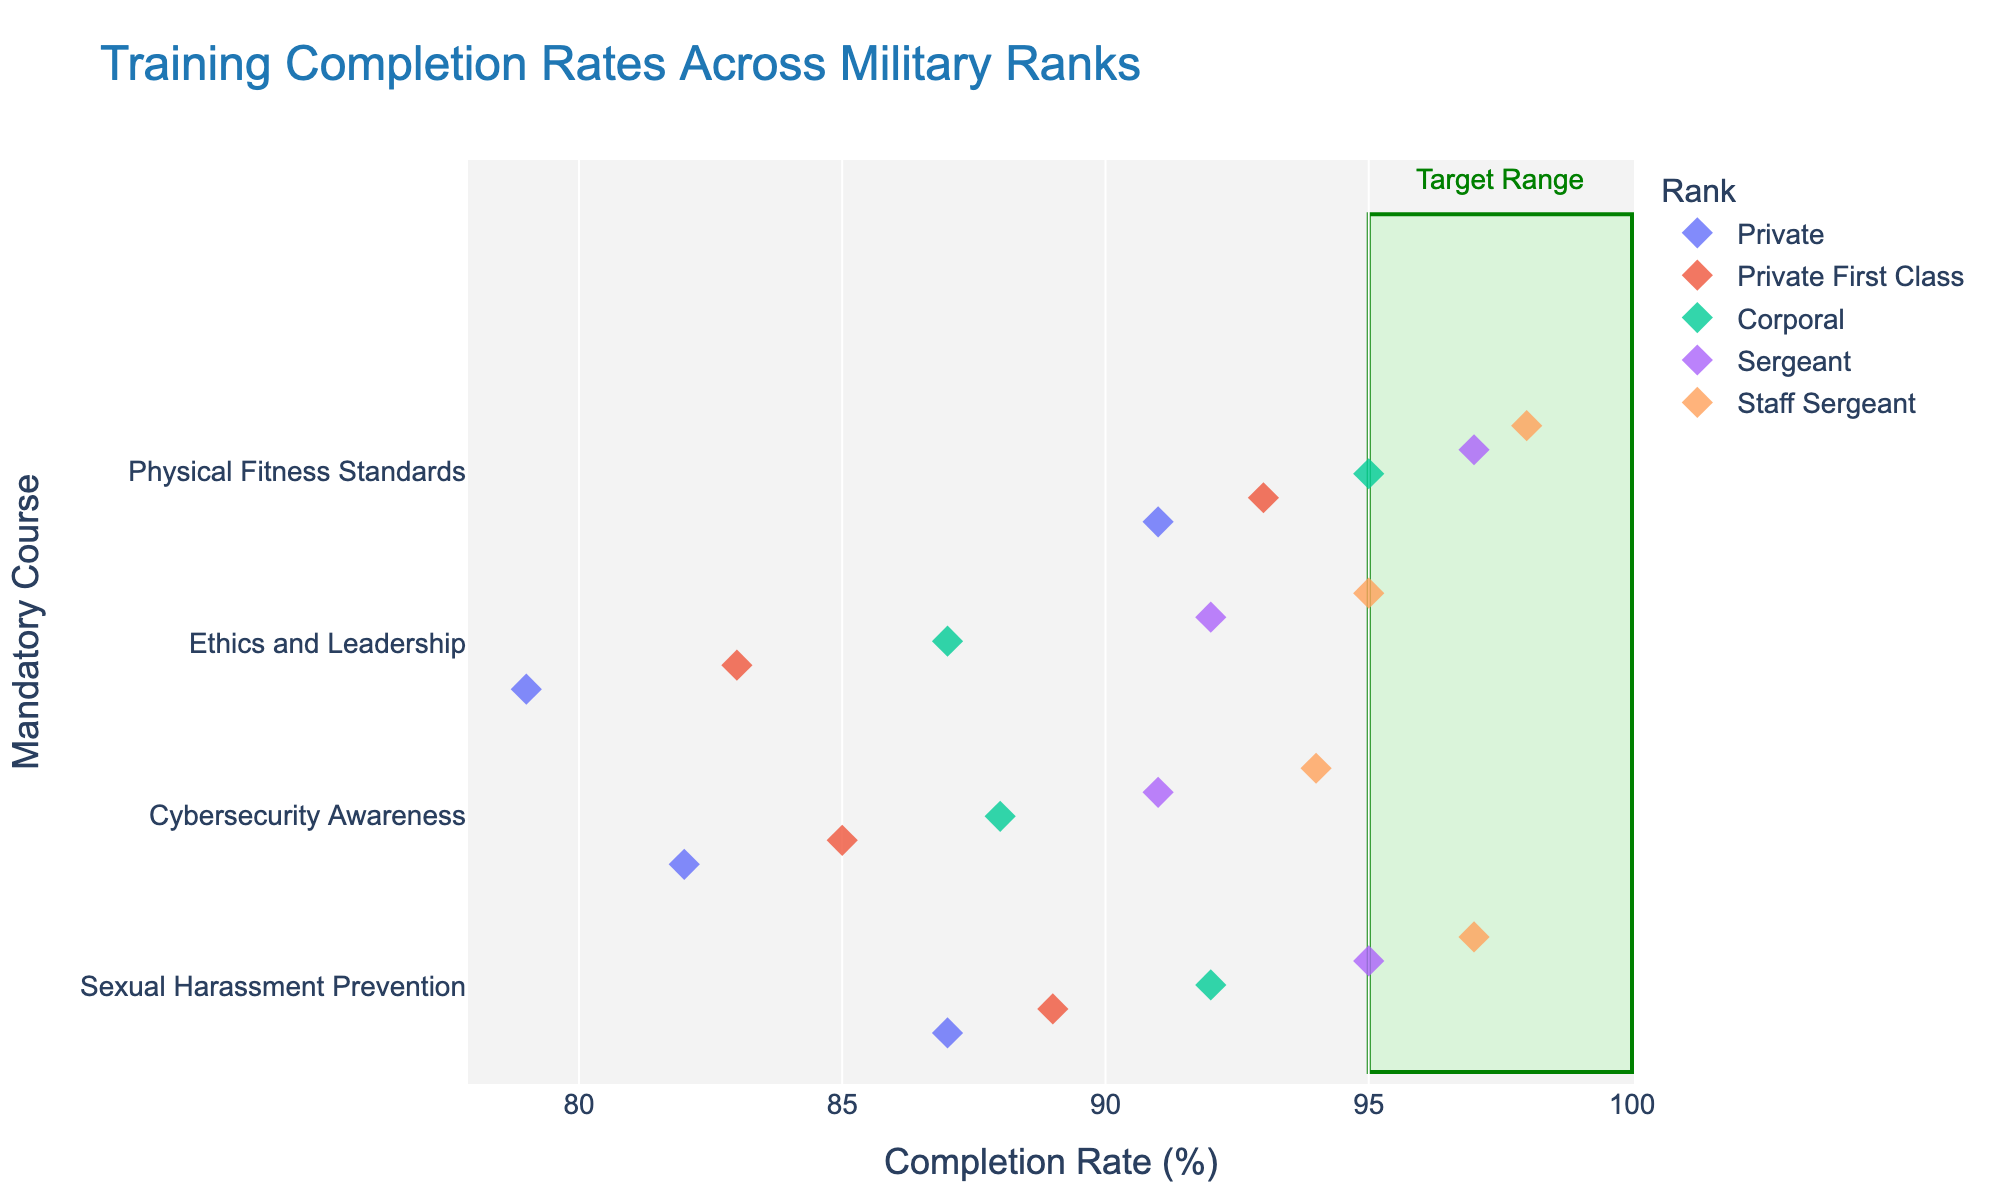what is the title of the figure? The title of the figure is displayed at the top and is often larger and bolder than other text elements.
Answer: Training Completion Rates Across Military Ranks What does the x-axis represent? The x-axis represents the "Completion Rate (%)" for the mandatory courses.
Answer: Completion Rate (%) How many distinct ranks are shown in the figure? The ranks are represented by different colors in the strip plot, and we can see five distinct colors.
Answer: Five (Private, Private First Class, Corporal, Sergeant, Staff Sergeant) Which course has the highest completion rate for the Private rank? For the Private rank, we look for the highest completion rate in the figure. The data points for this rank correspond to the lowest completion rate values.
Answer: Physical Fitness Standards What is the completion rate range highlighted by the green area? The highlighted range is specified by the green rectangular shape that spans the x-axis.
Answer: 95% to 100% Compare the completion rates of "Sexual Harassment Prevention" between Private and Staff Sergeant ranks. Locate the data points for the "Sexual Harassment Prevention" course and compare the completion rates for Private and Staff Sergeant ranks.
Answer: Private: 87%, Staff Sergeant: 97% Which rank has the highest average completion rate across all courses? Compute the average completion rate for each rank across all courses and compare them, notice that by visual inspection, Staff Sergeant has visually consistent higher rates.
Answer: Staff Sergeant What is the average completion rate of "Cybersecurity Awareness" for all ranks combined? Calculate the mean of the completion rates for "Cybersecurity Awareness" across all ranks (82 + 85 + 88 + 91 + 94) / 5 = 440 / 5.
Answer: 88% Does any rank fall below the 80% completion rate for any course? By scanning the lower bound of all ranks for each course, we can verify that none fall below 80%.
Answer: No For which course is the completion rate within the target range (95-100%) for all ranks? Identify courses where completion rates of all ranks fall within the highlighted target range on the x-axis.
Answer: Physical Fitness Standards 